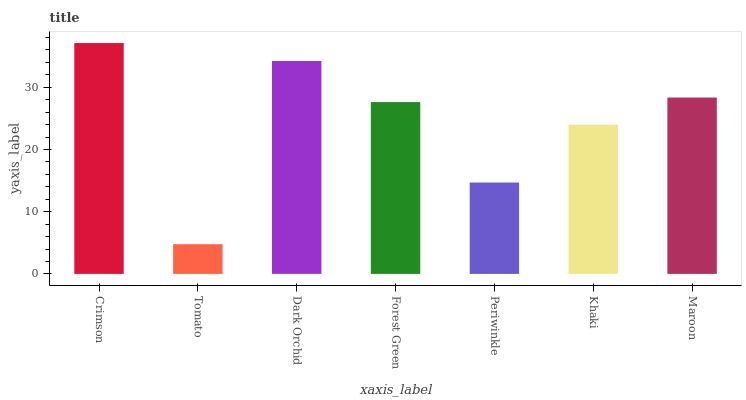Is Tomato the minimum?
Answer yes or no. Yes. Is Crimson the maximum?
Answer yes or no. Yes. Is Dark Orchid the minimum?
Answer yes or no. No. Is Dark Orchid the maximum?
Answer yes or no. No. Is Dark Orchid greater than Tomato?
Answer yes or no. Yes. Is Tomato less than Dark Orchid?
Answer yes or no. Yes. Is Tomato greater than Dark Orchid?
Answer yes or no. No. Is Dark Orchid less than Tomato?
Answer yes or no. No. Is Forest Green the high median?
Answer yes or no. Yes. Is Forest Green the low median?
Answer yes or no. Yes. Is Periwinkle the high median?
Answer yes or no. No. Is Tomato the low median?
Answer yes or no. No. 